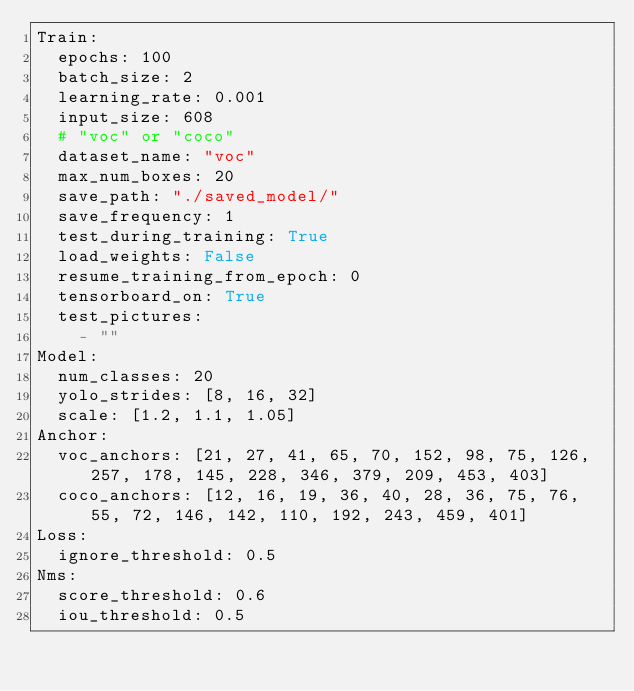<code> <loc_0><loc_0><loc_500><loc_500><_YAML_>Train:
  epochs: 100
  batch_size: 2
  learning_rate: 0.001
  input_size: 608
  # "voc" or "coco"
  dataset_name: "voc"
  max_num_boxes: 20
  save_path: "./saved_model/"
  save_frequency: 1
  test_during_training: True
  load_weights: False
  resume_training_from_epoch: 0
  tensorboard_on: True
  test_pictures:
    - ""
Model:
  num_classes: 20
  yolo_strides: [8, 16, 32]
  scale: [1.2, 1.1, 1.05]
Anchor:
  voc_anchors: [21, 27, 41, 65, 70, 152, 98, 75, 126, 257, 178, 145, 228, 346, 379, 209, 453, 403]
  coco_anchors: [12, 16, 19, 36, 40, 28, 36, 75, 76, 55, 72, 146, 142, 110, 192, 243, 459, 401]
Loss:
  ignore_threshold: 0.5
Nms:
  score_threshold: 0.6
  iou_threshold: 0.5
</code> 